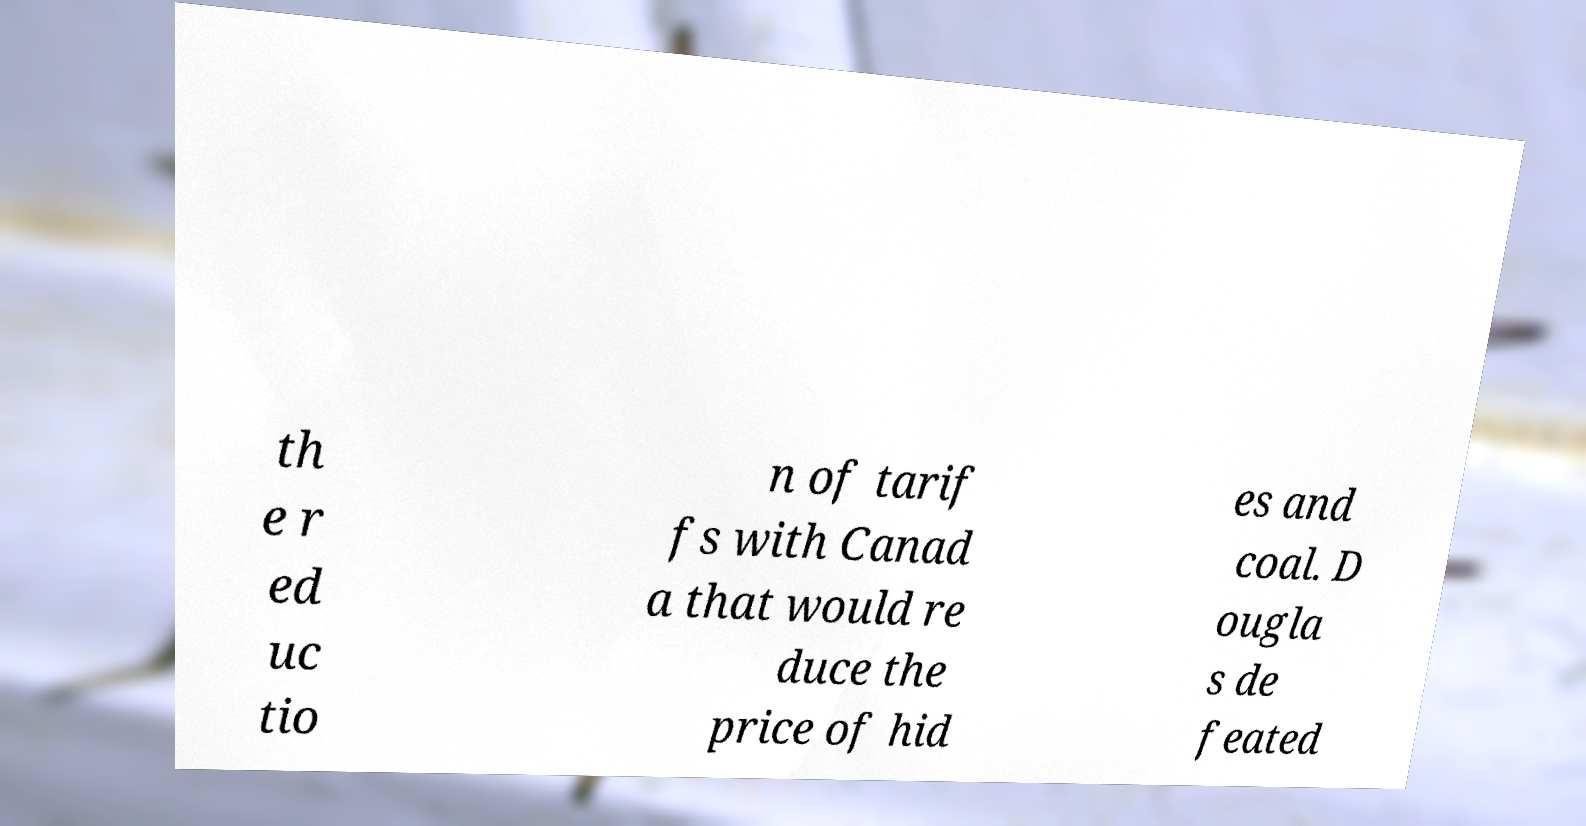There's text embedded in this image that I need extracted. Can you transcribe it verbatim? th e r ed uc tio n of tarif fs with Canad a that would re duce the price of hid es and coal. D ougla s de feated 